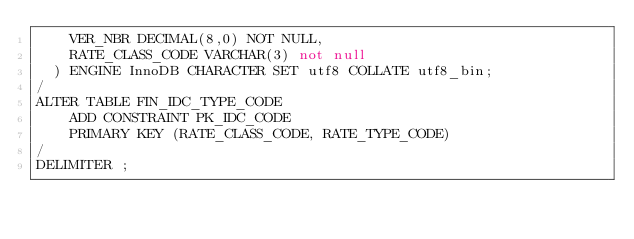<code> <loc_0><loc_0><loc_500><loc_500><_SQL_>    VER_NBR DECIMAL(8,0) NOT NULL,
    RATE_CLASS_CODE VARCHAR(3) not null
  ) ENGINE InnoDB CHARACTER SET utf8 COLLATE utf8_bin;
/
ALTER TABLE FIN_IDC_TYPE_CODE
    ADD CONSTRAINT PK_IDC_CODE
    PRIMARY KEY (RATE_CLASS_CODE, RATE_TYPE_CODE)
/
DELIMITER ;
</code> 